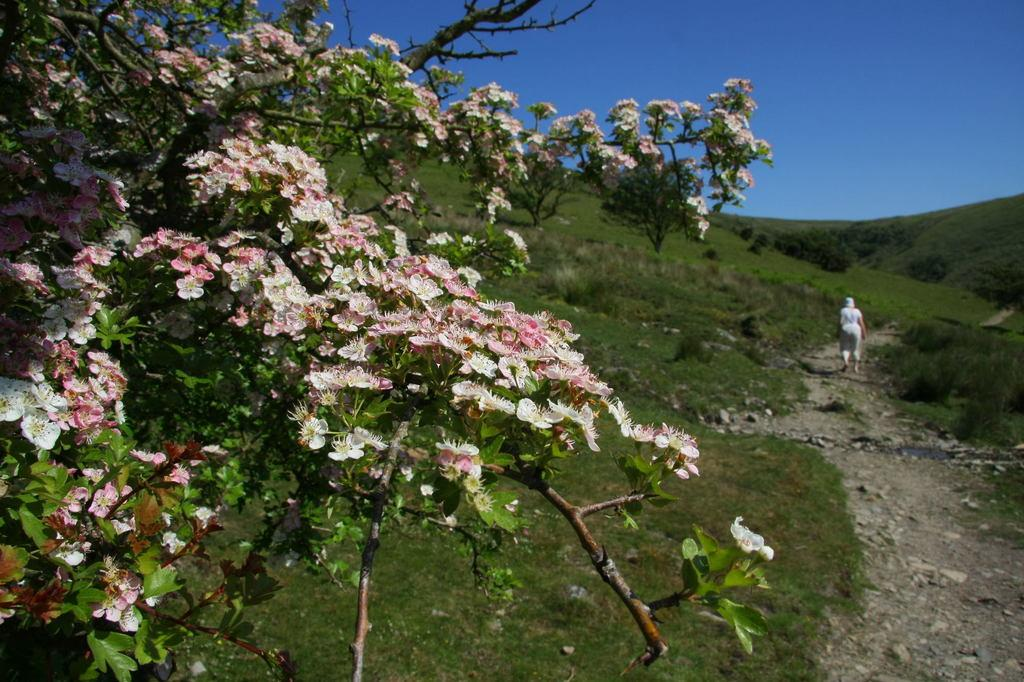What type of plants can be seen in the image? There are flowers, leaves, and stems in the image. What is the ground covered with in the image? The land is covered with grass in the image. What is the person in the image doing? There is a person walking on the ground in the image. What color is the sky in the image? The sky is blue in the image. What beginner skill is the person in the image trying to learn? There is no indication in the image that the person is trying to learn a beginner skill. What children's toy can be seen in the image? There are no children's toys present in the image. 